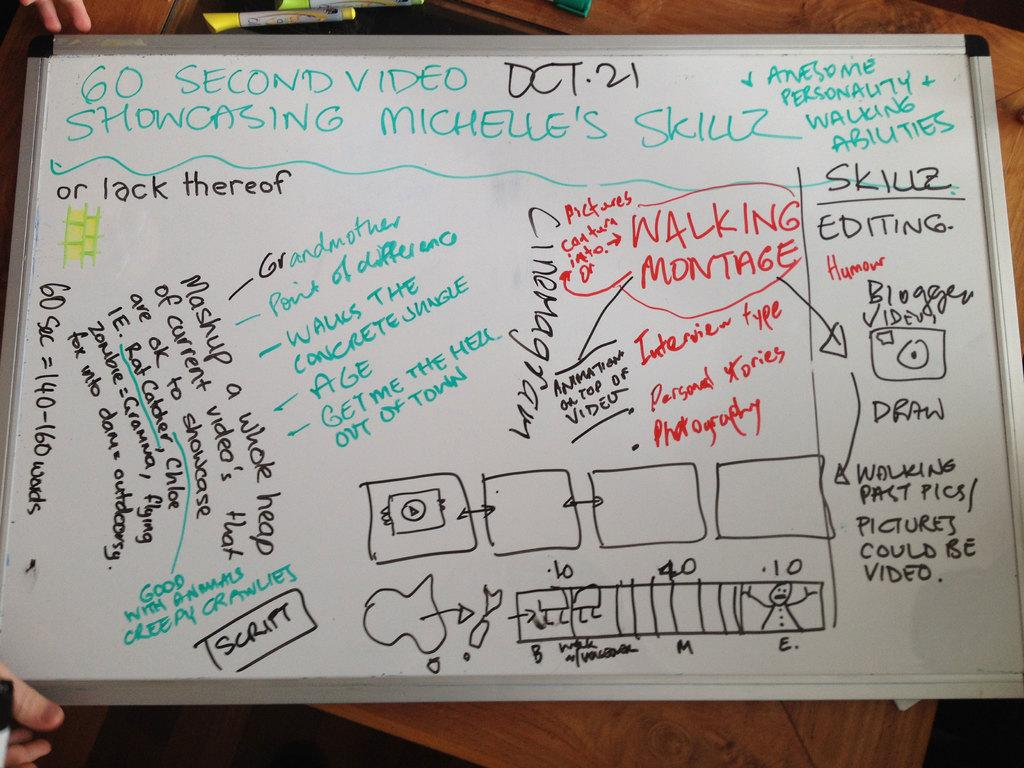<image>
Write a terse but informative summary of the picture. A dry erase board is covered in notes about editing. 